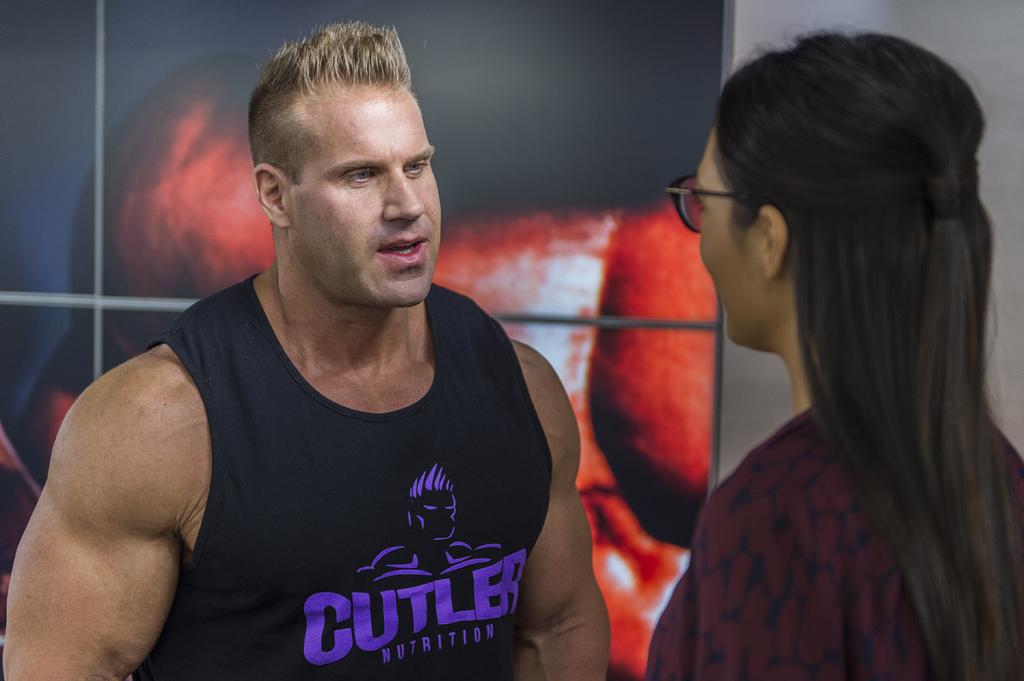What is the name of the nutrition company?
Offer a very short reply. Cutler. 